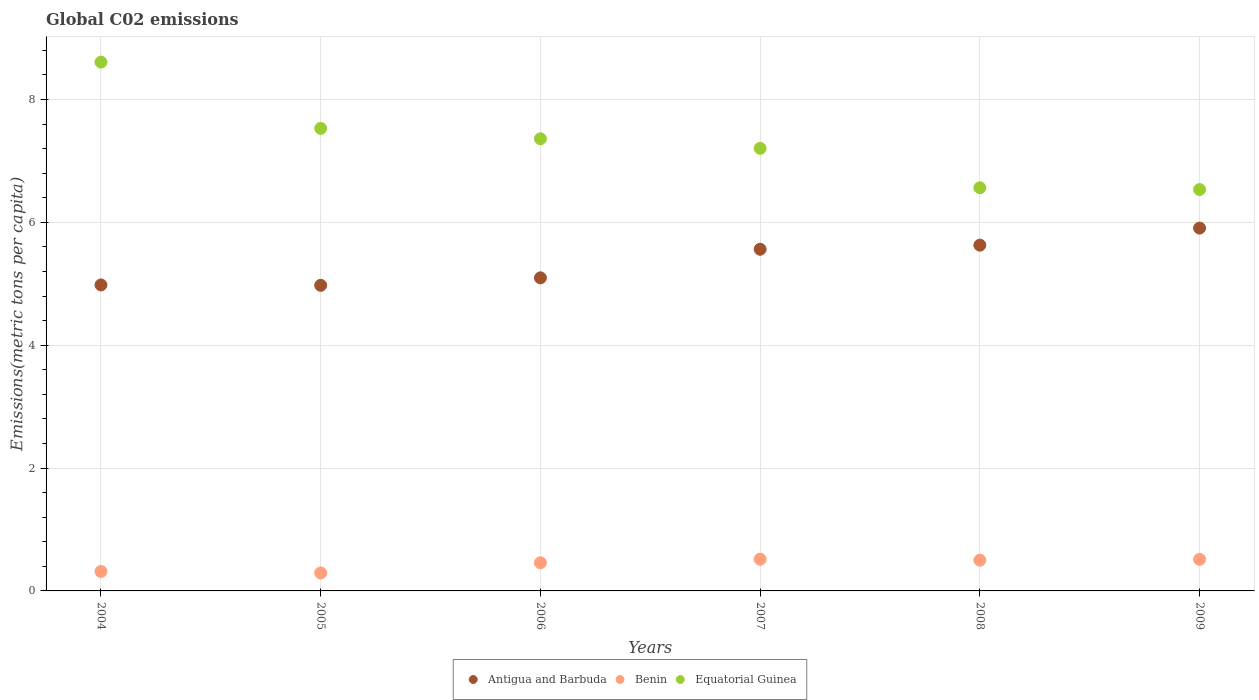What is the amount of CO2 emitted in in Equatorial Guinea in 2005?
Provide a succinct answer. 7.53. Across all years, what is the maximum amount of CO2 emitted in in Equatorial Guinea?
Your answer should be compact. 8.61. Across all years, what is the minimum amount of CO2 emitted in in Antigua and Barbuda?
Your response must be concise. 4.97. In which year was the amount of CO2 emitted in in Equatorial Guinea maximum?
Offer a terse response. 2004. In which year was the amount of CO2 emitted in in Equatorial Guinea minimum?
Your answer should be compact. 2009. What is the total amount of CO2 emitted in in Benin in the graph?
Offer a very short reply. 2.6. What is the difference between the amount of CO2 emitted in in Equatorial Guinea in 2005 and that in 2006?
Your answer should be very brief. 0.17. What is the difference between the amount of CO2 emitted in in Antigua and Barbuda in 2004 and the amount of CO2 emitted in in Benin in 2007?
Offer a very short reply. 4.46. What is the average amount of CO2 emitted in in Equatorial Guinea per year?
Offer a terse response. 7.3. In the year 2004, what is the difference between the amount of CO2 emitted in in Antigua and Barbuda and amount of CO2 emitted in in Benin?
Your answer should be very brief. 4.66. What is the ratio of the amount of CO2 emitted in in Antigua and Barbuda in 2005 to that in 2009?
Provide a short and direct response. 0.84. Is the difference between the amount of CO2 emitted in in Antigua and Barbuda in 2004 and 2009 greater than the difference between the amount of CO2 emitted in in Benin in 2004 and 2009?
Give a very brief answer. No. What is the difference between the highest and the second highest amount of CO2 emitted in in Benin?
Ensure brevity in your answer.  0. What is the difference between the highest and the lowest amount of CO2 emitted in in Antigua and Barbuda?
Provide a succinct answer. 0.93. In how many years, is the amount of CO2 emitted in in Antigua and Barbuda greater than the average amount of CO2 emitted in in Antigua and Barbuda taken over all years?
Your response must be concise. 3. Is the sum of the amount of CO2 emitted in in Benin in 2005 and 2009 greater than the maximum amount of CO2 emitted in in Antigua and Barbuda across all years?
Give a very brief answer. No. Is it the case that in every year, the sum of the amount of CO2 emitted in in Benin and amount of CO2 emitted in in Equatorial Guinea  is greater than the amount of CO2 emitted in in Antigua and Barbuda?
Your answer should be compact. Yes. Does the amount of CO2 emitted in in Antigua and Barbuda monotonically increase over the years?
Ensure brevity in your answer.  No. Is the amount of CO2 emitted in in Benin strictly greater than the amount of CO2 emitted in in Antigua and Barbuda over the years?
Your answer should be compact. No. Is the amount of CO2 emitted in in Benin strictly less than the amount of CO2 emitted in in Antigua and Barbuda over the years?
Ensure brevity in your answer.  Yes. Are the values on the major ticks of Y-axis written in scientific E-notation?
Your answer should be compact. No. Does the graph contain any zero values?
Make the answer very short. No. Where does the legend appear in the graph?
Keep it short and to the point. Bottom center. How many legend labels are there?
Offer a terse response. 3. How are the legend labels stacked?
Your answer should be very brief. Horizontal. What is the title of the graph?
Ensure brevity in your answer.  Global C02 emissions. Does "Portugal" appear as one of the legend labels in the graph?
Your answer should be compact. No. What is the label or title of the X-axis?
Provide a succinct answer. Years. What is the label or title of the Y-axis?
Provide a short and direct response. Emissions(metric tons per capita). What is the Emissions(metric tons per capita) of Antigua and Barbuda in 2004?
Provide a succinct answer. 4.98. What is the Emissions(metric tons per capita) in Benin in 2004?
Offer a very short reply. 0.32. What is the Emissions(metric tons per capita) of Equatorial Guinea in 2004?
Provide a short and direct response. 8.61. What is the Emissions(metric tons per capita) in Antigua and Barbuda in 2005?
Provide a short and direct response. 4.97. What is the Emissions(metric tons per capita) in Benin in 2005?
Your answer should be very brief. 0.29. What is the Emissions(metric tons per capita) in Equatorial Guinea in 2005?
Keep it short and to the point. 7.53. What is the Emissions(metric tons per capita) of Antigua and Barbuda in 2006?
Provide a succinct answer. 5.1. What is the Emissions(metric tons per capita) of Benin in 2006?
Your answer should be compact. 0.46. What is the Emissions(metric tons per capita) in Equatorial Guinea in 2006?
Your response must be concise. 7.36. What is the Emissions(metric tons per capita) of Antigua and Barbuda in 2007?
Your response must be concise. 5.56. What is the Emissions(metric tons per capita) in Benin in 2007?
Give a very brief answer. 0.52. What is the Emissions(metric tons per capita) in Equatorial Guinea in 2007?
Offer a terse response. 7.2. What is the Emissions(metric tons per capita) in Antigua and Barbuda in 2008?
Offer a terse response. 5.63. What is the Emissions(metric tons per capita) in Benin in 2008?
Your answer should be very brief. 0.5. What is the Emissions(metric tons per capita) in Equatorial Guinea in 2008?
Keep it short and to the point. 6.56. What is the Emissions(metric tons per capita) in Antigua and Barbuda in 2009?
Keep it short and to the point. 5.91. What is the Emissions(metric tons per capita) in Benin in 2009?
Make the answer very short. 0.51. What is the Emissions(metric tons per capita) of Equatorial Guinea in 2009?
Your answer should be very brief. 6.53. Across all years, what is the maximum Emissions(metric tons per capita) in Antigua and Barbuda?
Offer a very short reply. 5.91. Across all years, what is the maximum Emissions(metric tons per capita) in Benin?
Ensure brevity in your answer.  0.52. Across all years, what is the maximum Emissions(metric tons per capita) of Equatorial Guinea?
Offer a very short reply. 8.61. Across all years, what is the minimum Emissions(metric tons per capita) of Antigua and Barbuda?
Make the answer very short. 4.97. Across all years, what is the minimum Emissions(metric tons per capita) of Benin?
Make the answer very short. 0.29. Across all years, what is the minimum Emissions(metric tons per capita) in Equatorial Guinea?
Make the answer very short. 6.53. What is the total Emissions(metric tons per capita) in Antigua and Barbuda in the graph?
Your answer should be very brief. 32.15. What is the total Emissions(metric tons per capita) of Benin in the graph?
Provide a short and direct response. 2.6. What is the total Emissions(metric tons per capita) of Equatorial Guinea in the graph?
Provide a succinct answer. 43.8. What is the difference between the Emissions(metric tons per capita) in Antigua and Barbuda in 2004 and that in 2005?
Ensure brevity in your answer.  0.01. What is the difference between the Emissions(metric tons per capita) of Benin in 2004 and that in 2005?
Provide a succinct answer. 0.02. What is the difference between the Emissions(metric tons per capita) in Equatorial Guinea in 2004 and that in 2005?
Your answer should be compact. 1.08. What is the difference between the Emissions(metric tons per capita) of Antigua and Barbuda in 2004 and that in 2006?
Provide a succinct answer. -0.12. What is the difference between the Emissions(metric tons per capita) in Benin in 2004 and that in 2006?
Give a very brief answer. -0.14. What is the difference between the Emissions(metric tons per capita) of Equatorial Guinea in 2004 and that in 2006?
Your answer should be very brief. 1.25. What is the difference between the Emissions(metric tons per capita) in Antigua and Barbuda in 2004 and that in 2007?
Give a very brief answer. -0.58. What is the difference between the Emissions(metric tons per capita) of Benin in 2004 and that in 2007?
Give a very brief answer. -0.2. What is the difference between the Emissions(metric tons per capita) of Equatorial Guinea in 2004 and that in 2007?
Your answer should be compact. 1.4. What is the difference between the Emissions(metric tons per capita) in Antigua and Barbuda in 2004 and that in 2008?
Keep it short and to the point. -0.65. What is the difference between the Emissions(metric tons per capita) in Benin in 2004 and that in 2008?
Offer a very short reply. -0.18. What is the difference between the Emissions(metric tons per capita) of Equatorial Guinea in 2004 and that in 2008?
Keep it short and to the point. 2.05. What is the difference between the Emissions(metric tons per capita) in Antigua and Barbuda in 2004 and that in 2009?
Provide a short and direct response. -0.93. What is the difference between the Emissions(metric tons per capita) of Benin in 2004 and that in 2009?
Ensure brevity in your answer.  -0.2. What is the difference between the Emissions(metric tons per capita) in Equatorial Guinea in 2004 and that in 2009?
Give a very brief answer. 2.07. What is the difference between the Emissions(metric tons per capita) of Antigua and Barbuda in 2005 and that in 2006?
Ensure brevity in your answer.  -0.12. What is the difference between the Emissions(metric tons per capita) in Benin in 2005 and that in 2006?
Provide a short and direct response. -0.17. What is the difference between the Emissions(metric tons per capita) of Equatorial Guinea in 2005 and that in 2006?
Provide a succinct answer. 0.17. What is the difference between the Emissions(metric tons per capita) in Antigua and Barbuda in 2005 and that in 2007?
Provide a short and direct response. -0.59. What is the difference between the Emissions(metric tons per capita) in Benin in 2005 and that in 2007?
Offer a very short reply. -0.22. What is the difference between the Emissions(metric tons per capita) in Equatorial Guinea in 2005 and that in 2007?
Your answer should be very brief. 0.32. What is the difference between the Emissions(metric tons per capita) in Antigua and Barbuda in 2005 and that in 2008?
Provide a short and direct response. -0.65. What is the difference between the Emissions(metric tons per capita) in Benin in 2005 and that in 2008?
Your answer should be compact. -0.21. What is the difference between the Emissions(metric tons per capita) in Equatorial Guinea in 2005 and that in 2008?
Make the answer very short. 0.97. What is the difference between the Emissions(metric tons per capita) in Antigua and Barbuda in 2005 and that in 2009?
Provide a short and direct response. -0.93. What is the difference between the Emissions(metric tons per capita) in Benin in 2005 and that in 2009?
Your answer should be compact. -0.22. What is the difference between the Emissions(metric tons per capita) in Equatorial Guinea in 2005 and that in 2009?
Offer a very short reply. 1. What is the difference between the Emissions(metric tons per capita) of Antigua and Barbuda in 2006 and that in 2007?
Your answer should be compact. -0.47. What is the difference between the Emissions(metric tons per capita) of Benin in 2006 and that in 2007?
Provide a short and direct response. -0.06. What is the difference between the Emissions(metric tons per capita) of Equatorial Guinea in 2006 and that in 2007?
Give a very brief answer. 0.16. What is the difference between the Emissions(metric tons per capita) of Antigua and Barbuda in 2006 and that in 2008?
Provide a short and direct response. -0.53. What is the difference between the Emissions(metric tons per capita) of Benin in 2006 and that in 2008?
Provide a succinct answer. -0.04. What is the difference between the Emissions(metric tons per capita) in Equatorial Guinea in 2006 and that in 2008?
Provide a short and direct response. 0.8. What is the difference between the Emissions(metric tons per capita) of Antigua and Barbuda in 2006 and that in 2009?
Keep it short and to the point. -0.81. What is the difference between the Emissions(metric tons per capita) in Benin in 2006 and that in 2009?
Keep it short and to the point. -0.06. What is the difference between the Emissions(metric tons per capita) of Equatorial Guinea in 2006 and that in 2009?
Your response must be concise. 0.83. What is the difference between the Emissions(metric tons per capita) in Antigua and Barbuda in 2007 and that in 2008?
Give a very brief answer. -0.07. What is the difference between the Emissions(metric tons per capita) in Benin in 2007 and that in 2008?
Ensure brevity in your answer.  0.02. What is the difference between the Emissions(metric tons per capita) in Equatorial Guinea in 2007 and that in 2008?
Ensure brevity in your answer.  0.64. What is the difference between the Emissions(metric tons per capita) of Antigua and Barbuda in 2007 and that in 2009?
Your response must be concise. -0.34. What is the difference between the Emissions(metric tons per capita) in Benin in 2007 and that in 2009?
Provide a short and direct response. 0. What is the difference between the Emissions(metric tons per capita) of Equatorial Guinea in 2007 and that in 2009?
Ensure brevity in your answer.  0.67. What is the difference between the Emissions(metric tons per capita) in Antigua and Barbuda in 2008 and that in 2009?
Offer a very short reply. -0.28. What is the difference between the Emissions(metric tons per capita) in Benin in 2008 and that in 2009?
Offer a very short reply. -0.01. What is the difference between the Emissions(metric tons per capita) of Equatorial Guinea in 2008 and that in 2009?
Make the answer very short. 0.03. What is the difference between the Emissions(metric tons per capita) of Antigua and Barbuda in 2004 and the Emissions(metric tons per capita) of Benin in 2005?
Provide a succinct answer. 4.69. What is the difference between the Emissions(metric tons per capita) of Antigua and Barbuda in 2004 and the Emissions(metric tons per capita) of Equatorial Guinea in 2005?
Give a very brief answer. -2.55. What is the difference between the Emissions(metric tons per capita) of Benin in 2004 and the Emissions(metric tons per capita) of Equatorial Guinea in 2005?
Provide a succinct answer. -7.21. What is the difference between the Emissions(metric tons per capita) of Antigua and Barbuda in 2004 and the Emissions(metric tons per capita) of Benin in 2006?
Give a very brief answer. 4.52. What is the difference between the Emissions(metric tons per capita) of Antigua and Barbuda in 2004 and the Emissions(metric tons per capita) of Equatorial Guinea in 2006?
Make the answer very short. -2.38. What is the difference between the Emissions(metric tons per capita) of Benin in 2004 and the Emissions(metric tons per capita) of Equatorial Guinea in 2006?
Offer a very short reply. -7.04. What is the difference between the Emissions(metric tons per capita) in Antigua and Barbuda in 2004 and the Emissions(metric tons per capita) in Benin in 2007?
Give a very brief answer. 4.46. What is the difference between the Emissions(metric tons per capita) of Antigua and Barbuda in 2004 and the Emissions(metric tons per capita) of Equatorial Guinea in 2007?
Offer a very short reply. -2.22. What is the difference between the Emissions(metric tons per capita) of Benin in 2004 and the Emissions(metric tons per capita) of Equatorial Guinea in 2007?
Provide a short and direct response. -6.89. What is the difference between the Emissions(metric tons per capita) of Antigua and Barbuda in 2004 and the Emissions(metric tons per capita) of Benin in 2008?
Provide a succinct answer. 4.48. What is the difference between the Emissions(metric tons per capita) of Antigua and Barbuda in 2004 and the Emissions(metric tons per capita) of Equatorial Guinea in 2008?
Provide a short and direct response. -1.58. What is the difference between the Emissions(metric tons per capita) in Benin in 2004 and the Emissions(metric tons per capita) in Equatorial Guinea in 2008?
Offer a very short reply. -6.25. What is the difference between the Emissions(metric tons per capita) of Antigua and Barbuda in 2004 and the Emissions(metric tons per capita) of Benin in 2009?
Give a very brief answer. 4.47. What is the difference between the Emissions(metric tons per capita) of Antigua and Barbuda in 2004 and the Emissions(metric tons per capita) of Equatorial Guinea in 2009?
Make the answer very short. -1.55. What is the difference between the Emissions(metric tons per capita) in Benin in 2004 and the Emissions(metric tons per capita) in Equatorial Guinea in 2009?
Give a very brief answer. -6.22. What is the difference between the Emissions(metric tons per capita) in Antigua and Barbuda in 2005 and the Emissions(metric tons per capita) in Benin in 2006?
Your response must be concise. 4.52. What is the difference between the Emissions(metric tons per capita) of Antigua and Barbuda in 2005 and the Emissions(metric tons per capita) of Equatorial Guinea in 2006?
Provide a short and direct response. -2.39. What is the difference between the Emissions(metric tons per capita) of Benin in 2005 and the Emissions(metric tons per capita) of Equatorial Guinea in 2006?
Keep it short and to the point. -7.07. What is the difference between the Emissions(metric tons per capita) in Antigua and Barbuda in 2005 and the Emissions(metric tons per capita) in Benin in 2007?
Your answer should be compact. 4.46. What is the difference between the Emissions(metric tons per capita) in Antigua and Barbuda in 2005 and the Emissions(metric tons per capita) in Equatorial Guinea in 2007?
Your answer should be very brief. -2.23. What is the difference between the Emissions(metric tons per capita) of Benin in 2005 and the Emissions(metric tons per capita) of Equatorial Guinea in 2007?
Provide a short and direct response. -6.91. What is the difference between the Emissions(metric tons per capita) of Antigua and Barbuda in 2005 and the Emissions(metric tons per capita) of Benin in 2008?
Keep it short and to the point. 4.47. What is the difference between the Emissions(metric tons per capita) of Antigua and Barbuda in 2005 and the Emissions(metric tons per capita) of Equatorial Guinea in 2008?
Your answer should be compact. -1.59. What is the difference between the Emissions(metric tons per capita) in Benin in 2005 and the Emissions(metric tons per capita) in Equatorial Guinea in 2008?
Provide a succinct answer. -6.27. What is the difference between the Emissions(metric tons per capita) of Antigua and Barbuda in 2005 and the Emissions(metric tons per capita) of Benin in 2009?
Offer a terse response. 4.46. What is the difference between the Emissions(metric tons per capita) in Antigua and Barbuda in 2005 and the Emissions(metric tons per capita) in Equatorial Guinea in 2009?
Provide a succinct answer. -1.56. What is the difference between the Emissions(metric tons per capita) in Benin in 2005 and the Emissions(metric tons per capita) in Equatorial Guinea in 2009?
Keep it short and to the point. -6.24. What is the difference between the Emissions(metric tons per capita) in Antigua and Barbuda in 2006 and the Emissions(metric tons per capita) in Benin in 2007?
Provide a succinct answer. 4.58. What is the difference between the Emissions(metric tons per capita) in Antigua and Barbuda in 2006 and the Emissions(metric tons per capita) in Equatorial Guinea in 2007?
Offer a very short reply. -2.11. What is the difference between the Emissions(metric tons per capita) of Benin in 2006 and the Emissions(metric tons per capita) of Equatorial Guinea in 2007?
Offer a very short reply. -6.75. What is the difference between the Emissions(metric tons per capita) in Antigua and Barbuda in 2006 and the Emissions(metric tons per capita) in Benin in 2008?
Offer a terse response. 4.6. What is the difference between the Emissions(metric tons per capita) of Antigua and Barbuda in 2006 and the Emissions(metric tons per capita) of Equatorial Guinea in 2008?
Ensure brevity in your answer.  -1.47. What is the difference between the Emissions(metric tons per capita) in Benin in 2006 and the Emissions(metric tons per capita) in Equatorial Guinea in 2008?
Make the answer very short. -6.1. What is the difference between the Emissions(metric tons per capita) in Antigua and Barbuda in 2006 and the Emissions(metric tons per capita) in Benin in 2009?
Offer a very short reply. 4.58. What is the difference between the Emissions(metric tons per capita) in Antigua and Barbuda in 2006 and the Emissions(metric tons per capita) in Equatorial Guinea in 2009?
Your answer should be very brief. -1.44. What is the difference between the Emissions(metric tons per capita) in Benin in 2006 and the Emissions(metric tons per capita) in Equatorial Guinea in 2009?
Your response must be concise. -6.08. What is the difference between the Emissions(metric tons per capita) of Antigua and Barbuda in 2007 and the Emissions(metric tons per capita) of Benin in 2008?
Ensure brevity in your answer.  5.06. What is the difference between the Emissions(metric tons per capita) of Antigua and Barbuda in 2007 and the Emissions(metric tons per capita) of Equatorial Guinea in 2008?
Your answer should be very brief. -1. What is the difference between the Emissions(metric tons per capita) in Benin in 2007 and the Emissions(metric tons per capita) in Equatorial Guinea in 2008?
Offer a very short reply. -6.05. What is the difference between the Emissions(metric tons per capita) of Antigua and Barbuda in 2007 and the Emissions(metric tons per capita) of Benin in 2009?
Offer a terse response. 5.05. What is the difference between the Emissions(metric tons per capita) of Antigua and Barbuda in 2007 and the Emissions(metric tons per capita) of Equatorial Guinea in 2009?
Provide a succinct answer. -0.97. What is the difference between the Emissions(metric tons per capita) in Benin in 2007 and the Emissions(metric tons per capita) in Equatorial Guinea in 2009?
Ensure brevity in your answer.  -6.02. What is the difference between the Emissions(metric tons per capita) in Antigua and Barbuda in 2008 and the Emissions(metric tons per capita) in Benin in 2009?
Keep it short and to the point. 5.11. What is the difference between the Emissions(metric tons per capita) of Antigua and Barbuda in 2008 and the Emissions(metric tons per capita) of Equatorial Guinea in 2009?
Your response must be concise. -0.91. What is the difference between the Emissions(metric tons per capita) in Benin in 2008 and the Emissions(metric tons per capita) in Equatorial Guinea in 2009?
Make the answer very short. -6.03. What is the average Emissions(metric tons per capita) of Antigua and Barbuda per year?
Your answer should be very brief. 5.36. What is the average Emissions(metric tons per capita) of Benin per year?
Provide a succinct answer. 0.43. What is the average Emissions(metric tons per capita) in Equatorial Guinea per year?
Your answer should be compact. 7.3. In the year 2004, what is the difference between the Emissions(metric tons per capita) of Antigua and Barbuda and Emissions(metric tons per capita) of Benin?
Your response must be concise. 4.66. In the year 2004, what is the difference between the Emissions(metric tons per capita) of Antigua and Barbuda and Emissions(metric tons per capita) of Equatorial Guinea?
Your answer should be compact. -3.63. In the year 2004, what is the difference between the Emissions(metric tons per capita) of Benin and Emissions(metric tons per capita) of Equatorial Guinea?
Keep it short and to the point. -8.29. In the year 2005, what is the difference between the Emissions(metric tons per capita) of Antigua and Barbuda and Emissions(metric tons per capita) of Benin?
Make the answer very short. 4.68. In the year 2005, what is the difference between the Emissions(metric tons per capita) in Antigua and Barbuda and Emissions(metric tons per capita) in Equatorial Guinea?
Give a very brief answer. -2.55. In the year 2005, what is the difference between the Emissions(metric tons per capita) in Benin and Emissions(metric tons per capita) in Equatorial Guinea?
Provide a succinct answer. -7.24. In the year 2006, what is the difference between the Emissions(metric tons per capita) in Antigua and Barbuda and Emissions(metric tons per capita) in Benin?
Ensure brevity in your answer.  4.64. In the year 2006, what is the difference between the Emissions(metric tons per capita) in Antigua and Barbuda and Emissions(metric tons per capita) in Equatorial Guinea?
Provide a succinct answer. -2.26. In the year 2006, what is the difference between the Emissions(metric tons per capita) in Benin and Emissions(metric tons per capita) in Equatorial Guinea?
Offer a terse response. -6.9. In the year 2007, what is the difference between the Emissions(metric tons per capita) in Antigua and Barbuda and Emissions(metric tons per capita) in Benin?
Provide a succinct answer. 5.05. In the year 2007, what is the difference between the Emissions(metric tons per capita) of Antigua and Barbuda and Emissions(metric tons per capita) of Equatorial Guinea?
Keep it short and to the point. -1.64. In the year 2007, what is the difference between the Emissions(metric tons per capita) in Benin and Emissions(metric tons per capita) in Equatorial Guinea?
Provide a short and direct response. -6.69. In the year 2008, what is the difference between the Emissions(metric tons per capita) of Antigua and Barbuda and Emissions(metric tons per capita) of Benin?
Offer a terse response. 5.13. In the year 2008, what is the difference between the Emissions(metric tons per capita) in Antigua and Barbuda and Emissions(metric tons per capita) in Equatorial Guinea?
Offer a terse response. -0.93. In the year 2008, what is the difference between the Emissions(metric tons per capita) in Benin and Emissions(metric tons per capita) in Equatorial Guinea?
Ensure brevity in your answer.  -6.06. In the year 2009, what is the difference between the Emissions(metric tons per capita) of Antigua and Barbuda and Emissions(metric tons per capita) of Benin?
Give a very brief answer. 5.39. In the year 2009, what is the difference between the Emissions(metric tons per capita) of Antigua and Barbuda and Emissions(metric tons per capita) of Equatorial Guinea?
Keep it short and to the point. -0.63. In the year 2009, what is the difference between the Emissions(metric tons per capita) of Benin and Emissions(metric tons per capita) of Equatorial Guinea?
Provide a succinct answer. -6.02. What is the ratio of the Emissions(metric tons per capita) in Antigua and Barbuda in 2004 to that in 2005?
Give a very brief answer. 1. What is the ratio of the Emissions(metric tons per capita) in Benin in 2004 to that in 2005?
Your response must be concise. 1.08. What is the ratio of the Emissions(metric tons per capita) of Equatorial Guinea in 2004 to that in 2005?
Make the answer very short. 1.14. What is the ratio of the Emissions(metric tons per capita) of Antigua and Barbuda in 2004 to that in 2006?
Your response must be concise. 0.98. What is the ratio of the Emissions(metric tons per capita) of Benin in 2004 to that in 2006?
Offer a terse response. 0.69. What is the ratio of the Emissions(metric tons per capita) of Equatorial Guinea in 2004 to that in 2006?
Give a very brief answer. 1.17. What is the ratio of the Emissions(metric tons per capita) of Antigua and Barbuda in 2004 to that in 2007?
Your response must be concise. 0.9. What is the ratio of the Emissions(metric tons per capita) in Benin in 2004 to that in 2007?
Your response must be concise. 0.61. What is the ratio of the Emissions(metric tons per capita) of Equatorial Guinea in 2004 to that in 2007?
Keep it short and to the point. 1.19. What is the ratio of the Emissions(metric tons per capita) in Antigua and Barbuda in 2004 to that in 2008?
Provide a succinct answer. 0.89. What is the ratio of the Emissions(metric tons per capita) in Benin in 2004 to that in 2008?
Your answer should be compact. 0.63. What is the ratio of the Emissions(metric tons per capita) of Equatorial Guinea in 2004 to that in 2008?
Offer a terse response. 1.31. What is the ratio of the Emissions(metric tons per capita) of Antigua and Barbuda in 2004 to that in 2009?
Your response must be concise. 0.84. What is the ratio of the Emissions(metric tons per capita) of Benin in 2004 to that in 2009?
Provide a short and direct response. 0.62. What is the ratio of the Emissions(metric tons per capita) in Equatorial Guinea in 2004 to that in 2009?
Make the answer very short. 1.32. What is the ratio of the Emissions(metric tons per capita) in Antigua and Barbuda in 2005 to that in 2006?
Offer a very short reply. 0.98. What is the ratio of the Emissions(metric tons per capita) of Benin in 2005 to that in 2006?
Your answer should be very brief. 0.64. What is the ratio of the Emissions(metric tons per capita) in Antigua and Barbuda in 2005 to that in 2007?
Make the answer very short. 0.89. What is the ratio of the Emissions(metric tons per capita) in Benin in 2005 to that in 2007?
Offer a very short reply. 0.57. What is the ratio of the Emissions(metric tons per capita) in Equatorial Guinea in 2005 to that in 2007?
Your response must be concise. 1.05. What is the ratio of the Emissions(metric tons per capita) in Antigua and Barbuda in 2005 to that in 2008?
Keep it short and to the point. 0.88. What is the ratio of the Emissions(metric tons per capita) in Benin in 2005 to that in 2008?
Your answer should be very brief. 0.59. What is the ratio of the Emissions(metric tons per capita) in Equatorial Guinea in 2005 to that in 2008?
Keep it short and to the point. 1.15. What is the ratio of the Emissions(metric tons per capita) in Antigua and Barbuda in 2005 to that in 2009?
Your answer should be very brief. 0.84. What is the ratio of the Emissions(metric tons per capita) of Benin in 2005 to that in 2009?
Provide a succinct answer. 0.57. What is the ratio of the Emissions(metric tons per capita) in Equatorial Guinea in 2005 to that in 2009?
Provide a succinct answer. 1.15. What is the ratio of the Emissions(metric tons per capita) in Antigua and Barbuda in 2006 to that in 2007?
Offer a very short reply. 0.92. What is the ratio of the Emissions(metric tons per capita) in Benin in 2006 to that in 2007?
Provide a succinct answer. 0.89. What is the ratio of the Emissions(metric tons per capita) in Equatorial Guinea in 2006 to that in 2007?
Offer a terse response. 1.02. What is the ratio of the Emissions(metric tons per capita) in Antigua and Barbuda in 2006 to that in 2008?
Give a very brief answer. 0.91. What is the ratio of the Emissions(metric tons per capita) in Benin in 2006 to that in 2008?
Offer a very short reply. 0.92. What is the ratio of the Emissions(metric tons per capita) in Equatorial Guinea in 2006 to that in 2008?
Make the answer very short. 1.12. What is the ratio of the Emissions(metric tons per capita) in Antigua and Barbuda in 2006 to that in 2009?
Make the answer very short. 0.86. What is the ratio of the Emissions(metric tons per capita) of Benin in 2006 to that in 2009?
Your answer should be very brief. 0.89. What is the ratio of the Emissions(metric tons per capita) of Equatorial Guinea in 2006 to that in 2009?
Ensure brevity in your answer.  1.13. What is the ratio of the Emissions(metric tons per capita) in Antigua and Barbuda in 2007 to that in 2008?
Offer a very short reply. 0.99. What is the ratio of the Emissions(metric tons per capita) of Benin in 2007 to that in 2008?
Your answer should be compact. 1.03. What is the ratio of the Emissions(metric tons per capita) in Equatorial Guinea in 2007 to that in 2008?
Give a very brief answer. 1.1. What is the ratio of the Emissions(metric tons per capita) in Antigua and Barbuda in 2007 to that in 2009?
Your answer should be very brief. 0.94. What is the ratio of the Emissions(metric tons per capita) of Benin in 2007 to that in 2009?
Offer a very short reply. 1. What is the ratio of the Emissions(metric tons per capita) of Equatorial Guinea in 2007 to that in 2009?
Offer a very short reply. 1.1. What is the ratio of the Emissions(metric tons per capita) in Antigua and Barbuda in 2008 to that in 2009?
Offer a terse response. 0.95. What is the ratio of the Emissions(metric tons per capita) in Benin in 2008 to that in 2009?
Offer a terse response. 0.97. What is the ratio of the Emissions(metric tons per capita) of Equatorial Guinea in 2008 to that in 2009?
Offer a terse response. 1. What is the difference between the highest and the second highest Emissions(metric tons per capita) in Antigua and Barbuda?
Your answer should be very brief. 0.28. What is the difference between the highest and the second highest Emissions(metric tons per capita) of Benin?
Give a very brief answer. 0. What is the difference between the highest and the second highest Emissions(metric tons per capita) in Equatorial Guinea?
Your answer should be very brief. 1.08. What is the difference between the highest and the lowest Emissions(metric tons per capita) in Antigua and Barbuda?
Provide a short and direct response. 0.93. What is the difference between the highest and the lowest Emissions(metric tons per capita) of Benin?
Your answer should be very brief. 0.22. What is the difference between the highest and the lowest Emissions(metric tons per capita) of Equatorial Guinea?
Offer a very short reply. 2.07. 